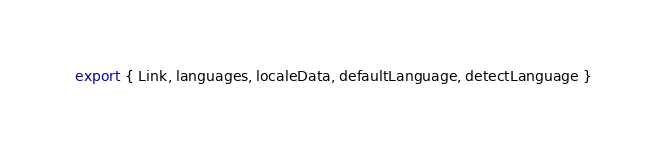Convert code to text. <code><loc_0><loc_0><loc_500><loc_500><_JavaScript_>export { Link, languages, localeData, defaultLanguage, detectLanguage }
</code> 